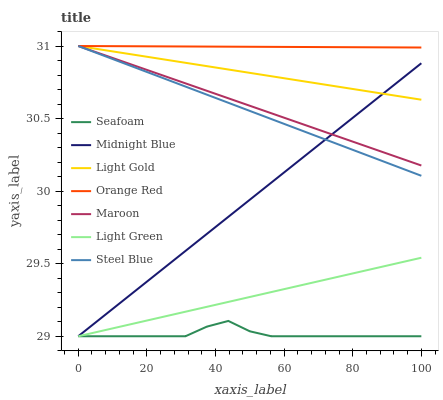Does Maroon have the minimum area under the curve?
Answer yes or no. No. Does Maroon have the maximum area under the curve?
Answer yes or no. No. Is Maroon the smoothest?
Answer yes or no. No. Is Maroon the roughest?
Answer yes or no. No. Does Maroon have the lowest value?
Answer yes or no. No. Does Seafoam have the highest value?
Answer yes or no. No. Is Seafoam less than Light Gold?
Answer yes or no. Yes. Is Maroon greater than Light Green?
Answer yes or no. Yes. Does Seafoam intersect Light Gold?
Answer yes or no. No. 